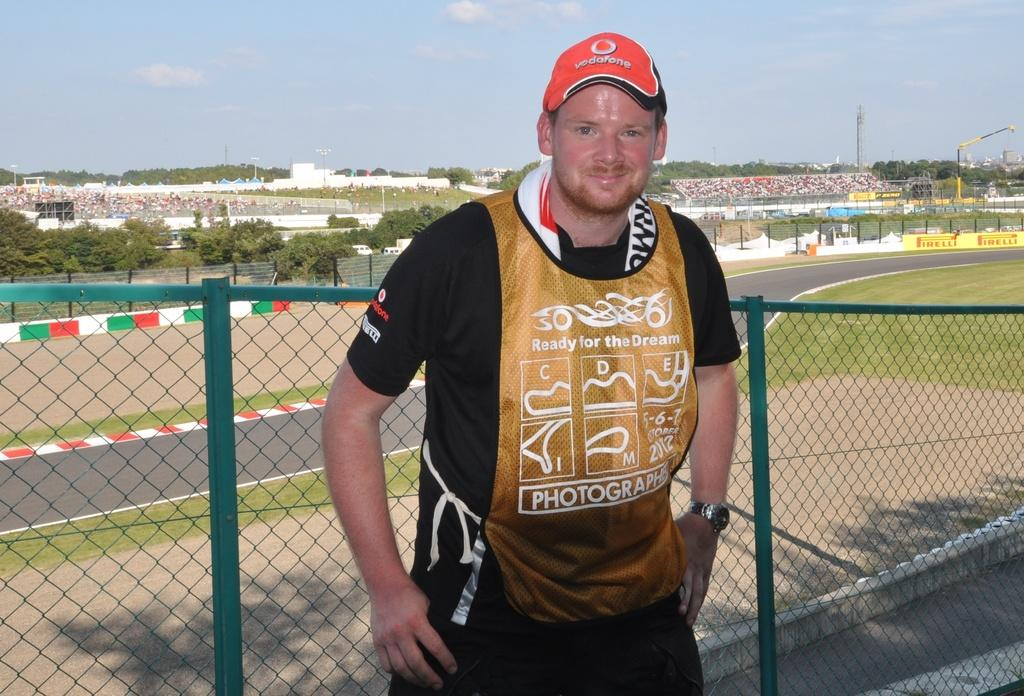<image>
Summarize the visual content of the image. Man wearing a yellow vest that says "Photography". 